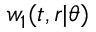<formula> <loc_0><loc_0><loc_500><loc_500>w _ { 1 } ( t , r | \theta )</formula> 